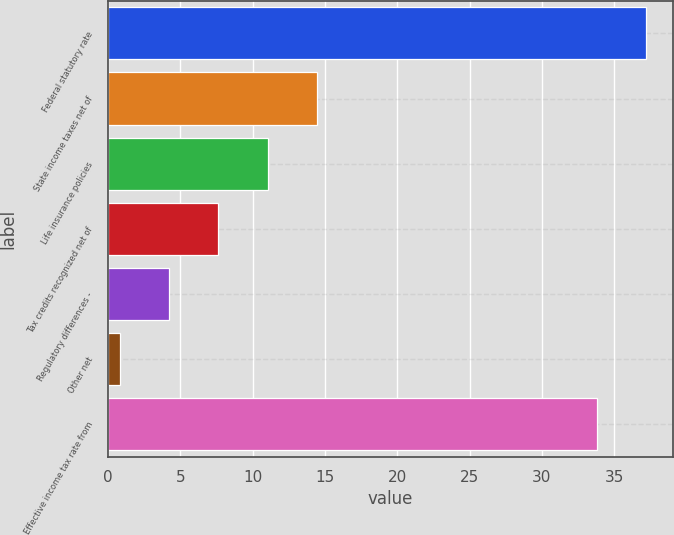Convert chart. <chart><loc_0><loc_0><loc_500><loc_500><bar_chart><fcel>Federal statutory rate<fcel>State income taxes net of<fcel>Life insurance policies<fcel>Tax credits recognized net of<fcel>Regulatory differences -<fcel>Other net<fcel>Effective income tax rate from<nl><fcel>37.22<fcel>14.48<fcel>11.06<fcel>7.64<fcel>4.22<fcel>0.8<fcel>33.8<nl></chart> 